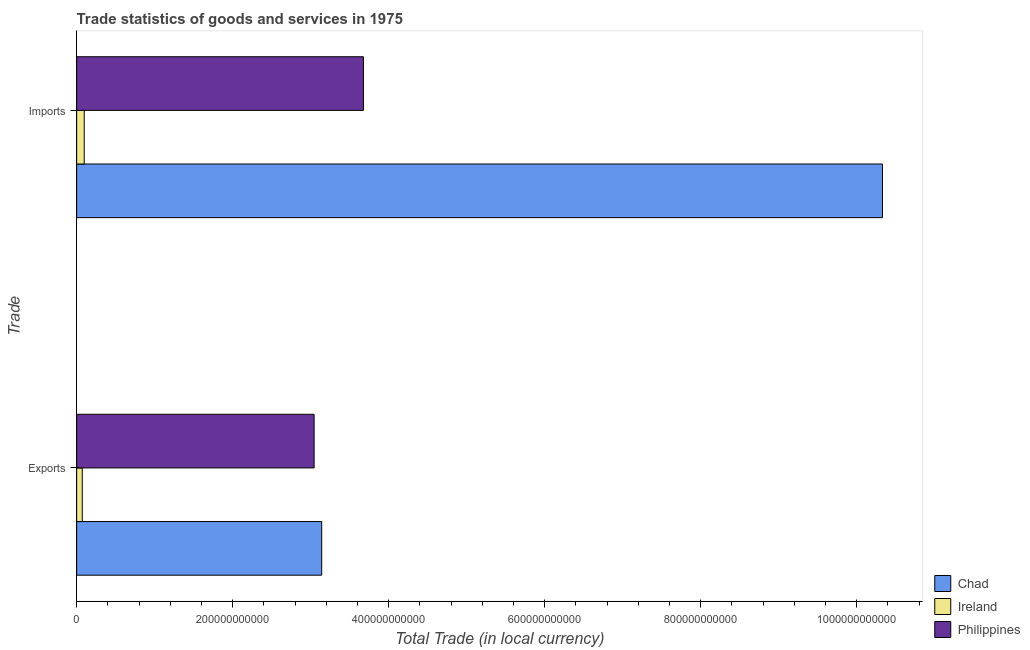Are the number of bars on each tick of the Y-axis equal?
Provide a short and direct response. Yes. How many bars are there on the 1st tick from the top?
Offer a very short reply. 3. How many bars are there on the 2nd tick from the bottom?
Make the answer very short. 3. What is the label of the 1st group of bars from the top?
Your response must be concise. Imports. What is the export of goods and services in Philippines?
Your response must be concise. 3.04e+11. Across all countries, what is the maximum imports of goods and services?
Provide a succinct answer. 1.03e+12. Across all countries, what is the minimum imports of goods and services?
Your answer should be very brief. 9.70e+09. In which country was the imports of goods and services maximum?
Your answer should be very brief. Chad. In which country was the imports of goods and services minimum?
Keep it short and to the point. Ireland. What is the total imports of goods and services in the graph?
Your answer should be compact. 1.41e+12. What is the difference between the export of goods and services in Philippines and that in Chad?
Your response must be concise. -9.75e+09. What is the difference between the export of goods and services in Philippines and the imports of goods and services in Chad?
Provide a short and direct response. -7.29e+11. What is the average imports of goods and services per country?
Provide a short and direct response. 4.70e+11. What is the difference between the imports of goods and services and export of goods and services in Philippines?
Your answer should be very brief. 6.32e+1. What is the ratio of the imports of goods and services in Philippines to that in Chad?
Offer a very short reply. 0.36. Is the imports of goods and services in Ireland less than that in Chad?
Make the answer very short. Yes. What does the 1st bar from the top in Exports represents?
Give a very brief answer. Philippines. How many countries are there in the graph?
Your answer should be very brief. 3. What is the difference between two consecutive major ticks on the X-axis?
Provide a short and direct response. 2.00e+11. Does the graph contain any zero values?
Ensure brevity in your answer.  No. How many legend labels are there?
Give a very brief answer. 3. What is the title of the graph?
Offer a terse response. Trade statistics of goods and services in 1975. What is the label or title of the X-axis?
Offer a terse response. Total Trade (in local currency). What is the label or title of the Y-axis?
Your answer should be very brief. Trade. What is the Total Trade (in local currency) in Chad in Exports?
Offer a terse response. 3.14e+11. What is the Total Trade (in local currency) of Ireland in Exports?
Provide a succinct answer. 7.18e+09. What is the Total Trade (in local currency) in Philippines in Exports?
Make the answer very short. 3.04e+11. What is the Total Trade (in local currency) in Chad in Imports?
Offer a terse response. 1.03e+12. What is the Total Trade (in local currency) in Ireland in Imports?
Provide a succinct answer. 9.70e+09. What is the Total Trade (in local currency) of Philippines in Imports?
Offer a very short reply. 3.68e+11. Across all Trade, what is the maximum Total Trade (in local currency) of Chad?
Provide a short and direct response. 1.03e+12. Across all Trade, what is the maximum Total Trade (in local currency) in Ireland?
Your response must be concise. 9.70e+09. Across all Trade, what is the maximum Total Trade (in local currency) in Philippines?
Offer a terse response. 3.68e+11. Across all Trade, what is the minimum Total Trade (in local currency) in Chad?
Give a very brief answer. 3.14e+11. Across all Trade, what is the minimum Total Trade (in local currency) in Ireland?
Ensure brevity in your answer.  7.18e+09. Across all Trade, what is the minimum Total Trade (in local currency) of Philippines?
Give a very brief answer. 3.04e+11. What is the total Total Trade (in local currency) in Chad in the graph?
Your answer should be very brief. 1.35e+12. What is the total Total Trade (in local currency) of Ireland in the graph?
Your answer should be very brief. 1.69e+1. What is the total Total Trade (in local currency) in Philippines in the graph?
Your answer should be very brief. 6.72e+11. What is the difference between the Total Trade (in local currency) in Chad in Exports and that in Imports?
Provide a short and direct response. -7.19e+11. What is the difference between the Total Trade (in local currency) of Ireland in Exports and that in Imports?
Provide a succinct answer. -2.52e+09. What is the difference between the Total Trade (in local currency) of Philippines in Exports and that in Imports?
Provide a succinct answer. -6.32e+1. What is the difference between the Total Trade (in local currency) of Chad in Exports and the Total Trade (in local currency) of Ireland in Imports?
Your response must be concise. 3.04e+11. What is the difference between the Total Trade (in local currency) of Chad in Exports and the Total Trade (in local currency) of Philippines in Imports?
Give a very brief answer. -5.35e+1. What is the difference between the Total Trade (in local currency) of Ireland in Exports and the Total Trade (in local currency) of Philippines in Imports?
Provide a short and direct response. -3.60e+11. What is the average Total Trade (in local currency) in Chad per Trade?
Provide a succinct answer. 6.74e+11. What is the average Total Trade (in local currency) in Ireland per Trade?
Your answer should be very brief. 8.44e+09. What is the average Total Trade (in local currency) in Philippines per Trade?
Your answer should be very brief. 3.36e+11. What is the difference between the Total Trade (in local currency) in Chad and Total Trade (in local currency) in Ireland in Exports?
Give a very brief answer. 3.07e+11. What is the difference between the Total Trade (in local currency) in Chad and Total Trade (in local currency) in Philippines in Exports?
Ensure brevity in your answer.  9.75e+09. What is the difference between the Total Trade (in local currency) in Ireland and Total Trade (in local currency) in Philippines in Exports?
Offer a terse response. -2.97e+11. What is the difference between the Total Trade (in local currency) in Chad and Total Trade (in local currency) in Ireland in Imports?
Ensure brevity in your answer.  1.02e+12. What is the difference between the Total Trade (in local currency) of Chad and Total Trade (in local currency) of Philippines in Imports?
Keep it short and to the point. 6.65e+11. What is the difference between the Total Trade (in local currency) in Ireland and Total Trade (in local currency) in Philippines in Imports?
Offer a very short reply. -3.58e+11. What is the ratio of the Total Trade (in local currency) in Chad in Exports to that in Imports?
Offer a very short reply. 0.3. What is the ratio of the Total Trade (in local currency) in Ireland in Exports to that in Imports?
Keep it short and to the point. 0.74. What is the ratio of the Total Trade (in local currency) of Philippines in Exports to that in Imports?
Provide a short and direct response. 0.83. What is the difference between the highest and the second highest Total Trade (in local currency) of Chad?
Your answer should be compact. 7.19e+11. What is the difference between the highest and the second highest Total Trade (in local currency) of Ireland?
Give a very brief answer. 2.52e+09. What is the difference between the highest and the second highest Total Trade (in local currency) of Philippines?
Your answer should be very brief. 6.32e+1. What is the difference between the highest and the lowest Total Trade (in local currency) of Chad?
Provide a succinct answer. 7.19e+11. What is the difference between the highest and the lowest Total Trade (in local currency) of Ireland?
Offer a terse response. 2.52e+09. What is the difference between the highest and the lowest Total Trade (in local currency) in Philippines?
Your response must be concise. 6.32e+1. 